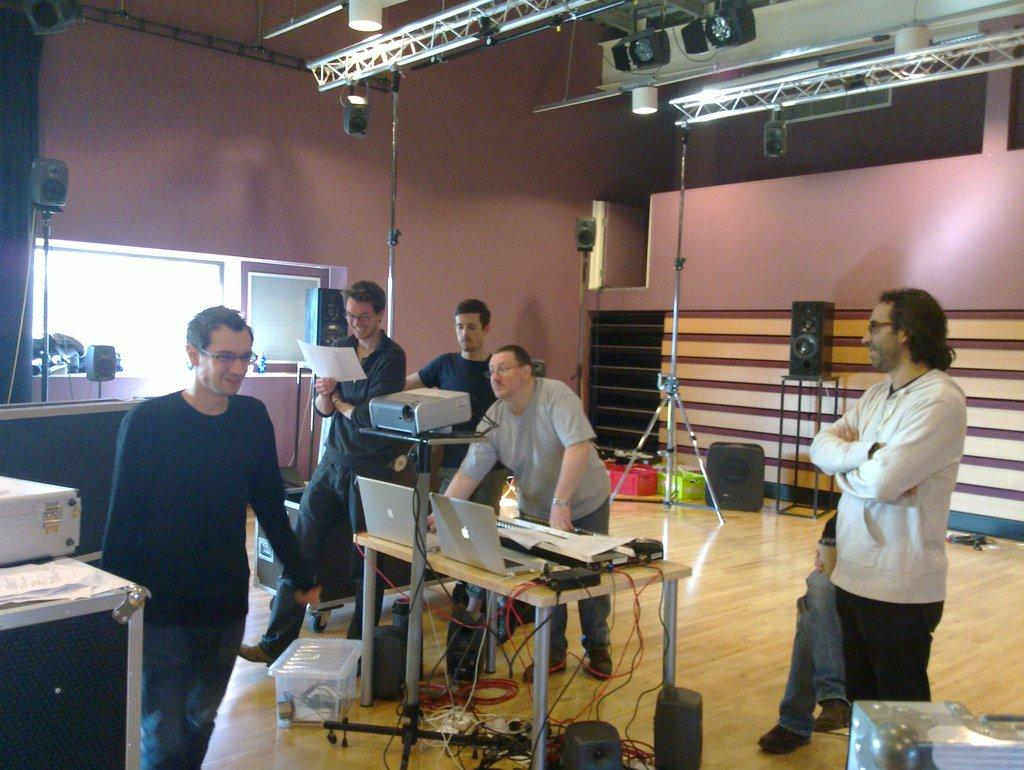How many persons are visible in the image? There are persons in the image. What electronic devices can be seen in the image? There are laptops in the image. What type of furniture is present in the image? There are tables in the image. What connects the devices in the image? There are wires in the image. What device is used for presenting visuals in the image? There is a projector in the image. What devices are used for amplifying sound in the image? There are speakers in the image. What type of lighting is present in the image? There are lights in the image. What architectural feature allows natural light to enter the room in the image? There are windows in the image. What type of support is present in the image? There are stands in the image. What type of wall is visible in the image? There is a wall in the image. What type of paper material is present in the image? There are papers in the image. What type of lighting fixture is present in the image? There is a tube light in the image. Can you tell me how many cherries are on the table in the image? There is no mention of cherries in the image; the provided facts do not mention any fruit. What type of donkey can be seen interacting with the persons in the image? There is no donkey present in the image; the provided facts do not mention any animals. 